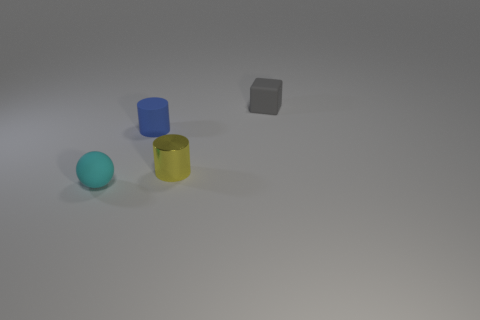Add 4 matte balls. How many objects exist? 8 Subtract 2 cylinders. How many cylinders are left? 0 Subtract all brown spheres. Subtract all blue matte cylinders. How many objects are left? 3 Add 3 cyan rubber spheres. How many cyan rubber spheres are left? 4 Add 4 red metallic blocks. How many red metallic blocks exist? 4 Subtract 0 brown balls. How many objects are left? 4 Subtract all cubes. How many objects are left? 3 Subtract all gray spheres. Subtract all yellow cubes. How many spheres are left? 1 Subtract all green spheres. How many yellow cylinders are left? 1 